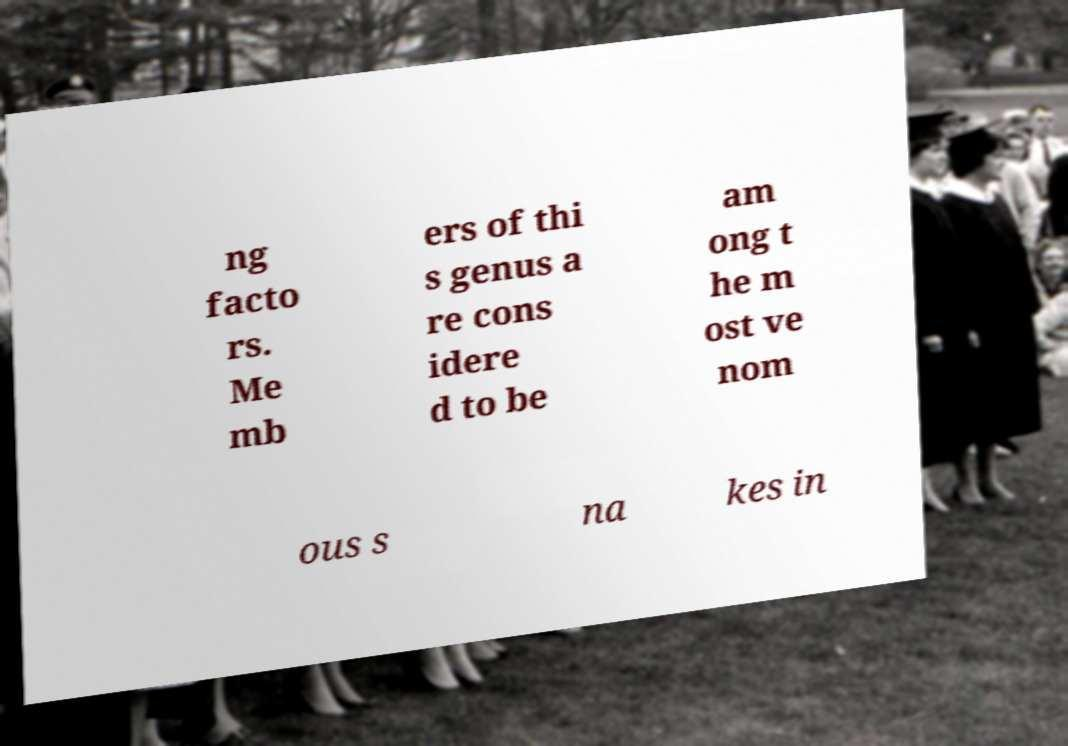Can you accurately transcribe the text from the provided image for me? ng facto rs. Me mb ers of thi s genus a re cons idere d to be am ong t he m ost ve nom ous s na kes in 